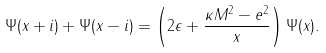Convert formula to latex. <formula><loc_0><loc_0><loc_500><loc_500>\Psi ( x + i ) + \Psi ( x - i ) = \left ( 2 \epsilon + \frac { \kappa M ^ { 2 } - e ^ { 2 } } { x } \right ) \Psi ( x ) .</formula> 